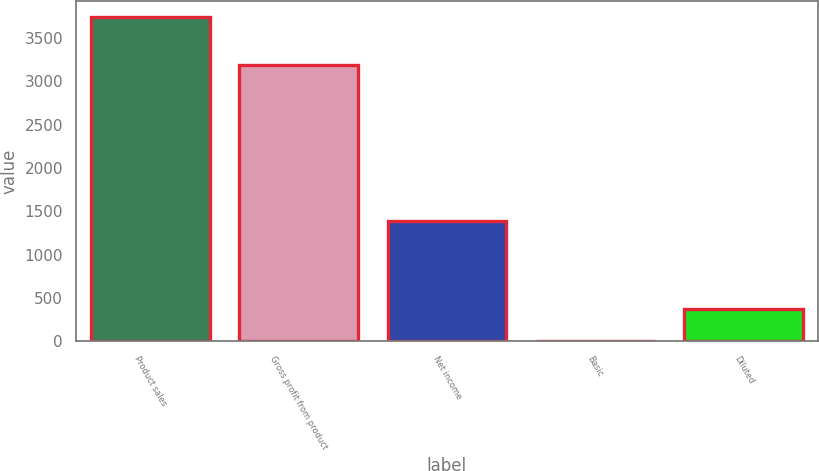Convert chart. <chart><loc_0><loc_0><loc_500><loc_500><bar_chart><fcel>Product sales<fcel>Gross profit from product<fcel>Net income<fcel>Basic<fcel>Diluted<nl><fcel>3736<fcel>3191<fcel>1386<fcel>1.36<fcel>374.82<nl></chart> 